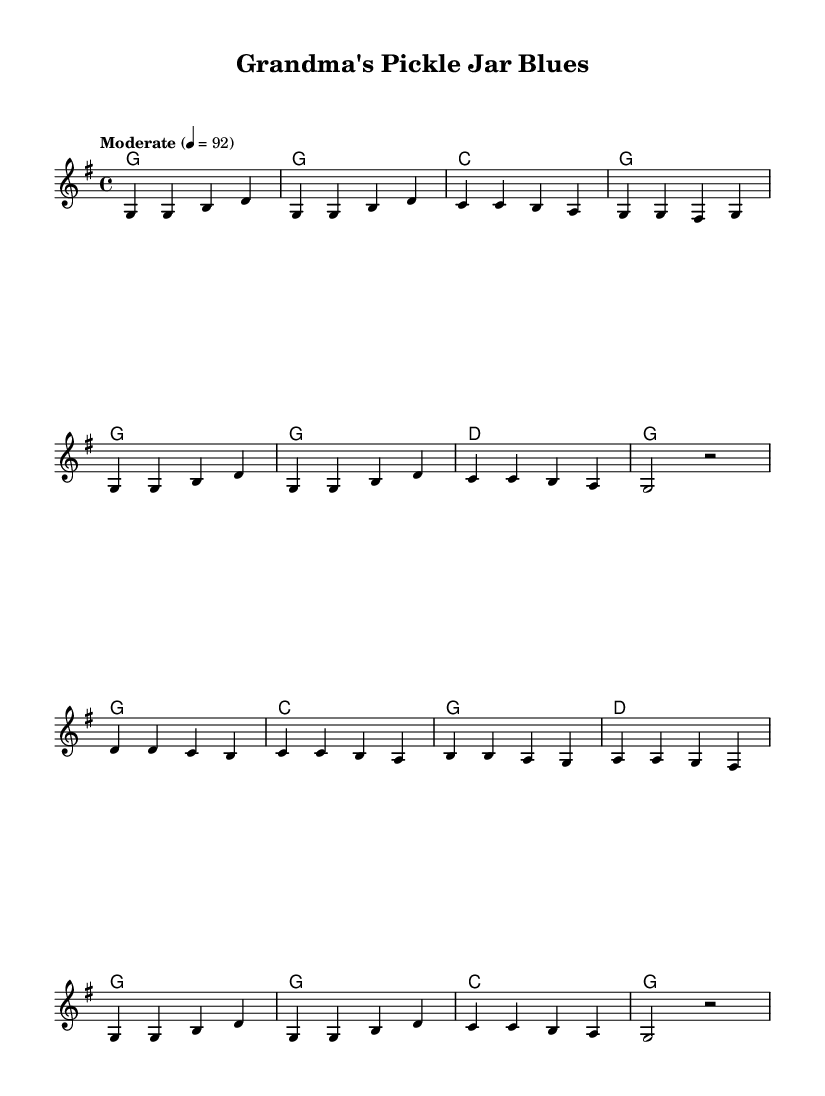What is the key signature of this music? The key signature is G major, which has one sharp (F#). This can be identified by looking at the beginning of the written music where the sharp symbol is placed, indicating the key in which the piece is composed.
Answer: G major What is the time signature of this music? The time signature is 4/4, indicated at the beginning of the composition. This means there are four beats in each measure, and the quarter note receives one beat.
Answer: 4/4 What tempo marking is indicated in the score? The tempo marking is "Moderate" with a beat of 92 per minute. This is typically shown above the staff and indicates the speed at which the music should be played.
Answer: Moderate 4 = 92 How many verses are in the song? There is one verse in the song, and it consists of a set of lyrics that corresponds to the melody. This can be determined by looking at the lyrics section, which introduces the verse before the chorus starts.
Answer: One What type of food is mentioned in the lyrics? The lyrics mention "pickles" and "sauerkraut." This can be answered by scanning the verse and chorus lyrics for any specific food references made during the song.
Answer: Pickles and sauerkraut What is the theme of the song? The theme of the song revolves around nostalgia and grandma's secret fermentation recipes. This can be inferred from the overall content of the lyrics, which reminisce about grandmother's cooking and its positive effects.
Answer: Nostalgia and fermentation 